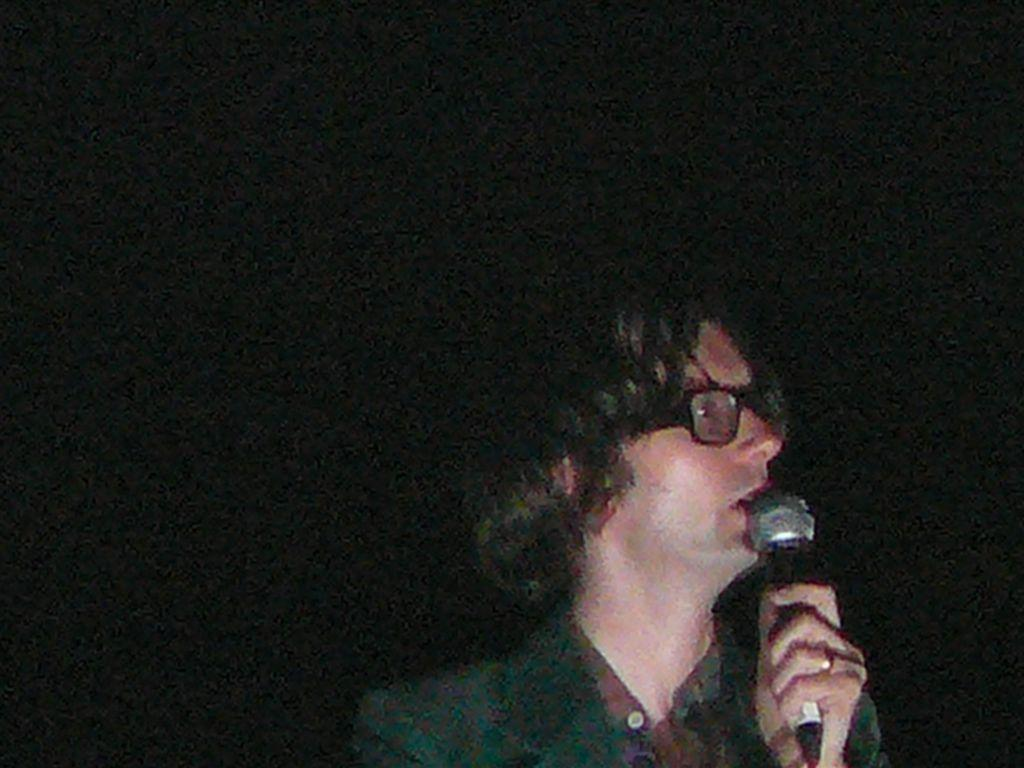What is the person in the image doing? The person is speaking into a microphone. What type of clothing is the person wearing on their upper body? The person is wearing a shirt and a coat. What accessory is the person wearing on their face? The person is wearing spectacles. What type of bit is the person using to control the band in the image? There is no band or bit present in the image; the person is simply speaking into a microphone. 